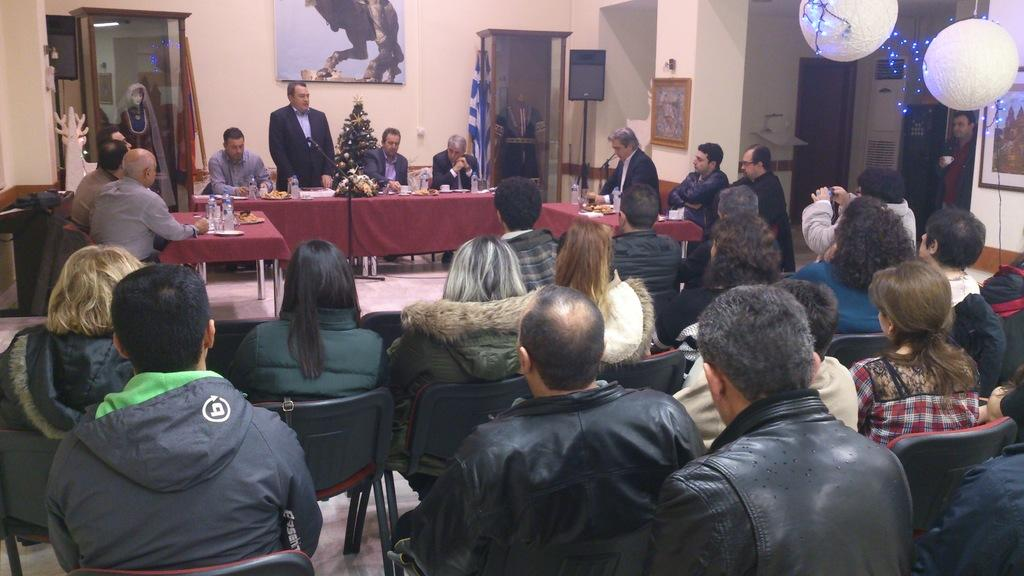What type of setting is shown in the image? The image depicts a meeting room. What are the people in the room doing? People are seated on chairs in the room. Is there anyone addressing the audience in the meeting room? Yes, there is a person standing and speaking to the audience. What type of connection can be seen between the board and the action in the image? There is no board or action involving a board present in the image. 